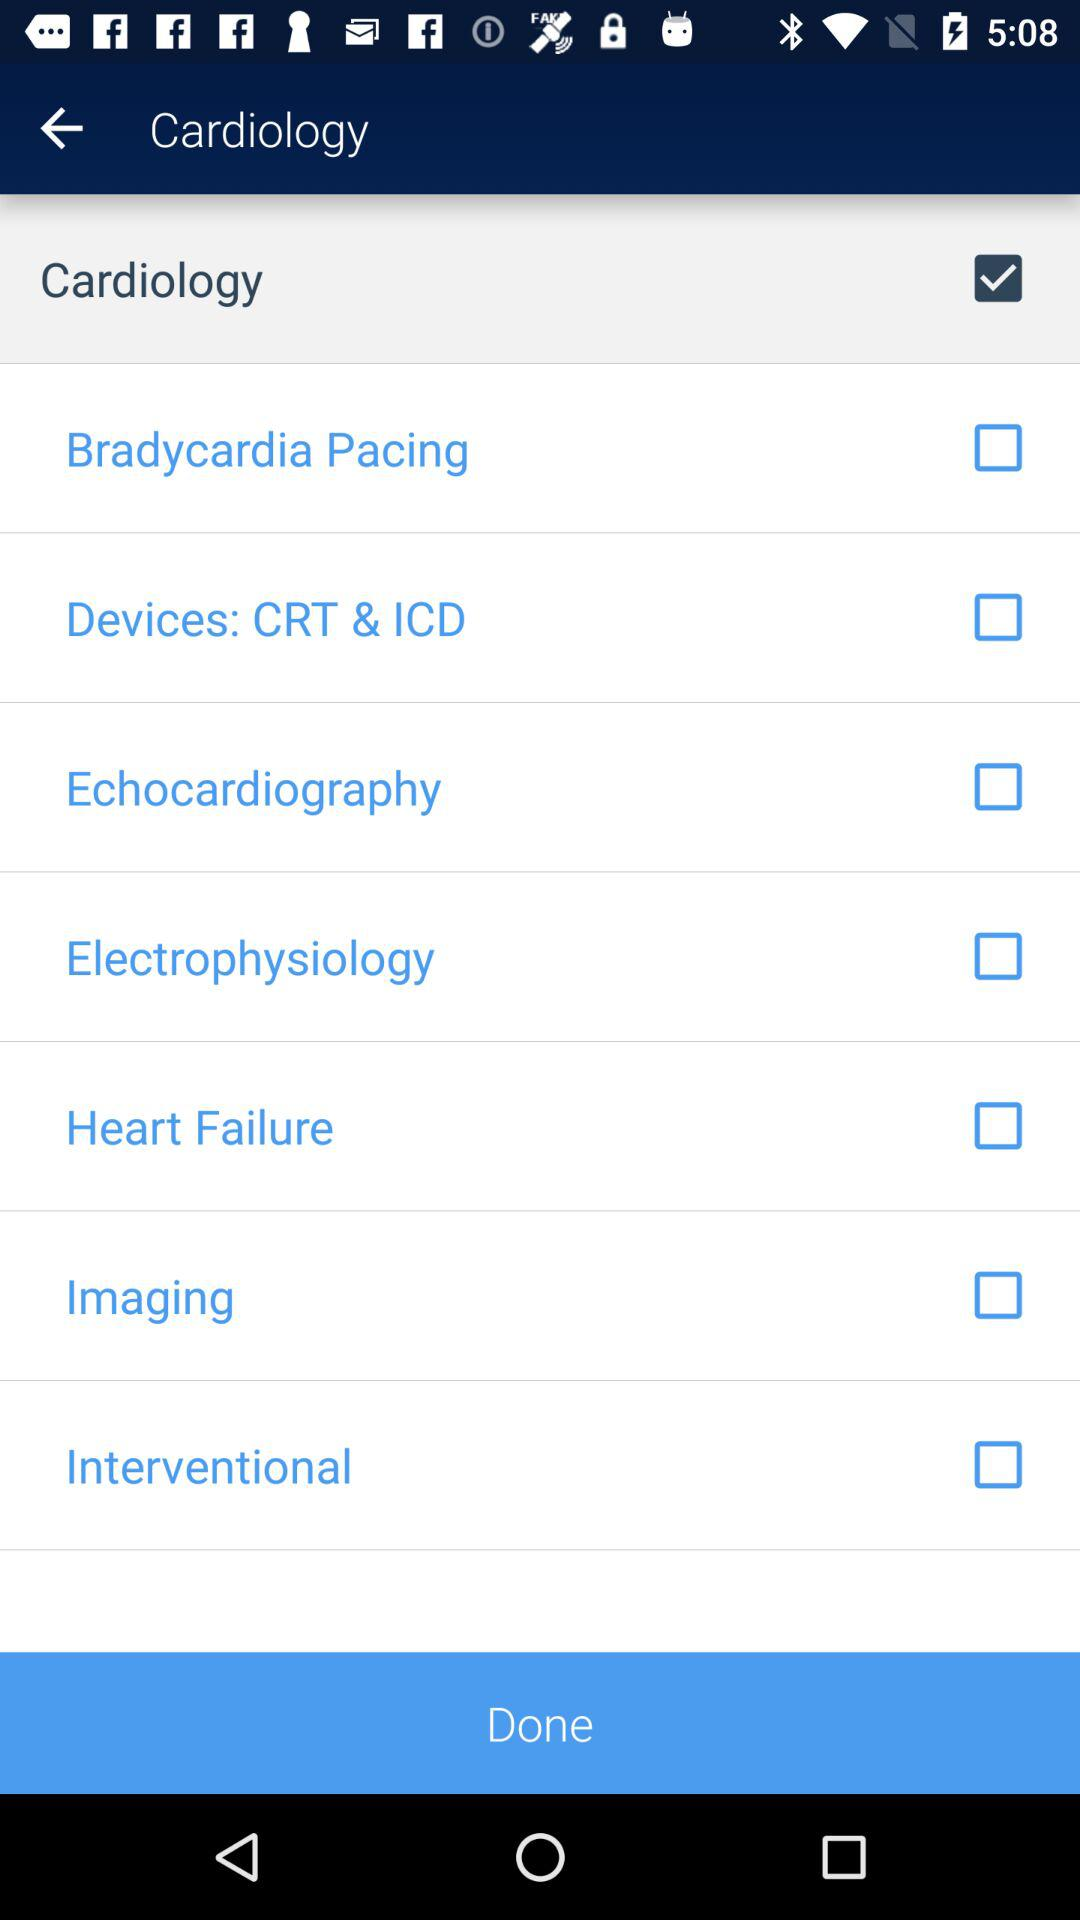What is the status of "Heart Failure"? The status is "off". 